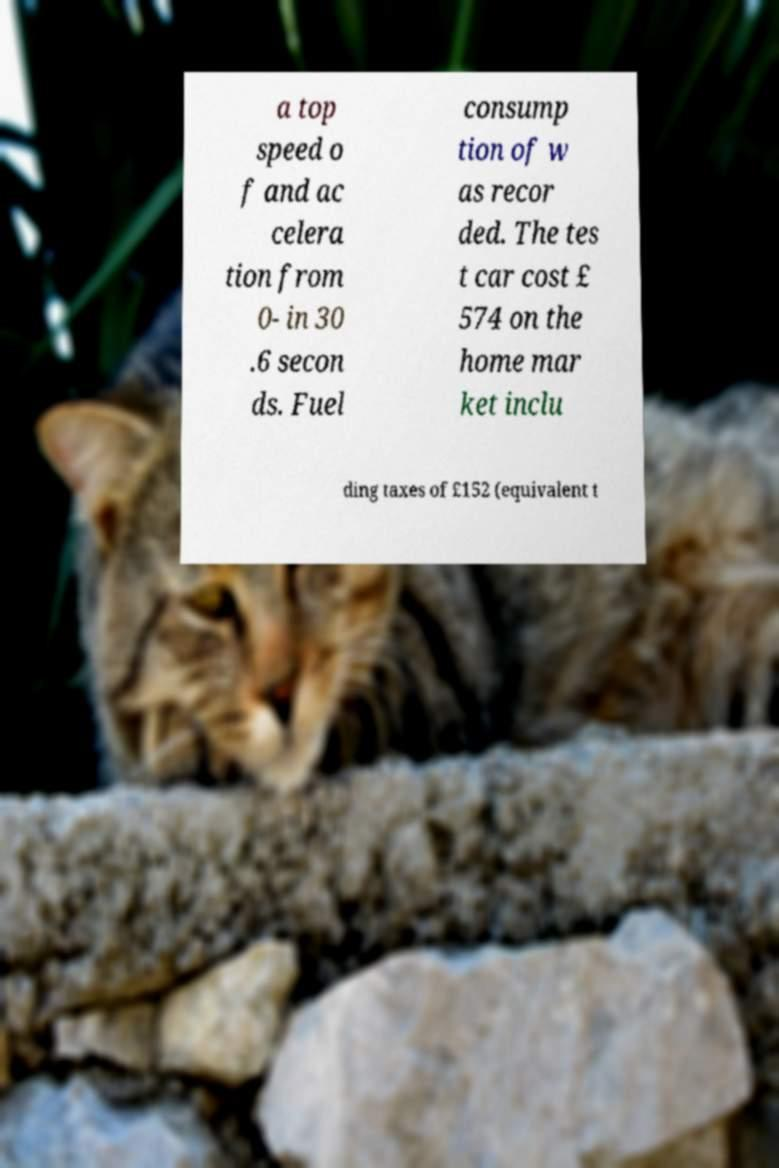What messages or text are displayed in this image? I need them in a readable, typed format. a top speed o f and ac celera tion from 0- in 30 .6 secon ds. Fuel consump tion of w as recor ded. The tes t car cost £ 574 on the home mar ket inclu ding taxes of £152 (equivalent t 